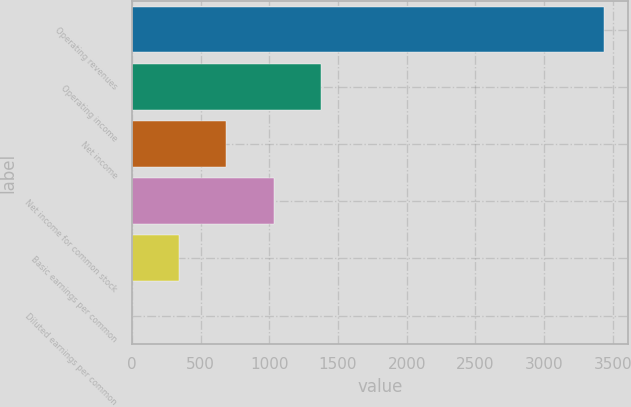<chart> <loc_0><loc_0><loc_500><loc_500><bar_chart><fcel>Operating revenues<fcel>Operating income<fcel>Net income<fcel>Net income for common stock<fcel>Basic earnings per common<fcel>Diluted earnings per common<nl><fcel>3438<fcel>1376.09<fcel>688.79<fcel>1032.44<fcel>345.14<fcel>1.49<nl></chart> 